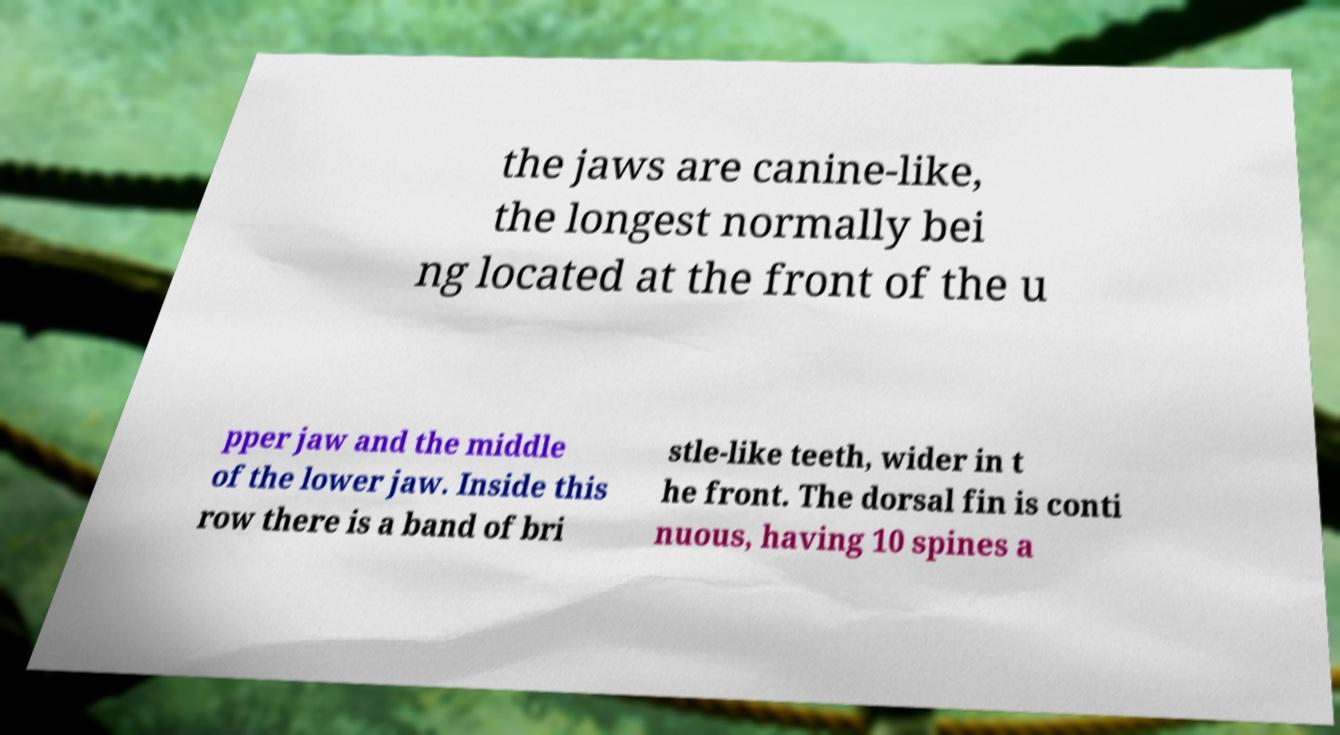There's text embedded in this image that I need extracted. Can you transcribe it verbatim? the jaws are canine-like, the longest normally bei ng located at the front of the u pper jaw and the middle of the lower jaw. Inside this row there is a band of bri stle-like teeth, wider in t he front. The dorsal fin is conti nuous, having 10 spines a 